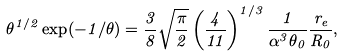<formula> <loc_0><loc_0><loc_500><loc_500>\theta ^ { 1 / 2 } \exp ( - 1 / \theta ) = \frac { 3 } { 8 } \sqrt { \frac { \pi } { 2 } } \left ( \frac { 4 } { 1 1 } \right ) ^ { 1 / 3 } \frac { 1 } { \alpha ^ { 3 } \theta _ { 0 } } \frac { r _ { e } } { R _ { 0 } } ,</formula> 